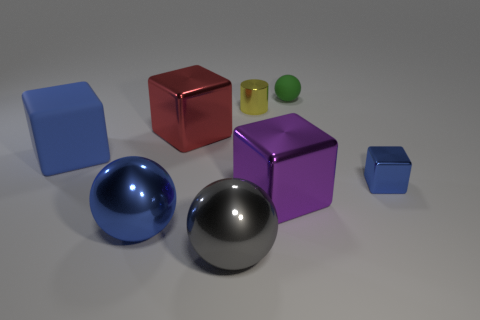How many brown matte blocks are there?
Keep it short and to the point. 0. What shape is the purple object that is the same material as the blue ball?
Make the answer very short. Cube. Is there any other thing of the same color as the rubber ball?
Keep it short and to the point. No. There is a big rubber block; is it the same color as the large metal block to the right of the large gray sphere?
Provide a short and direct response. No. Is the number of large blocks right of the big blue metal ball less than the number of small balls?
Your answer should be compact. No. What is the material of the big thing that is on the right side of the gray shiny thing?
Your answer should be very brief. Metal. What number of other things are the same size as the green thing?
Make the answer very short. 2. There is a red thing; does it have the same size as the blue block on the right side of the green rubber object?
Provide a short and direct response. No. There is a blue metallic object in front of the blue thing on the right side of the ball on the right side of the large purple thing; what is its shape?
Keep it short and to the point. Sphere. Are there fewer tiny metal cylinders than small shiny objects?
Provide a short and direct response. Yes. 